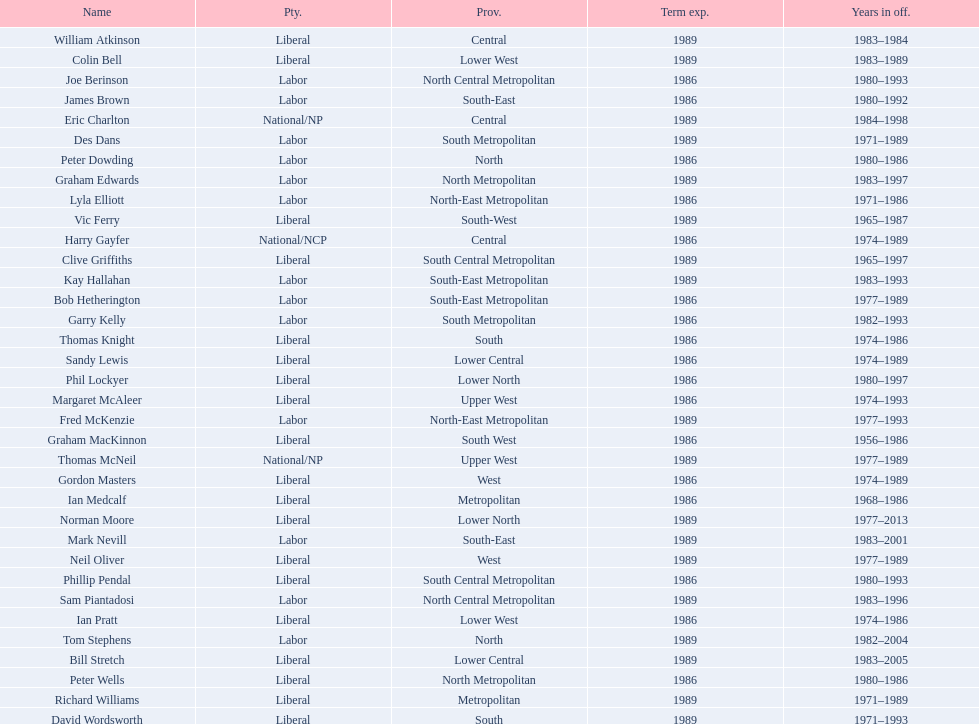What is the number of people in the liberal party? 19. 